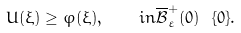<formula> <loc_0><loc_0><loc_500><loc_500>U ( \xi ) \geq \varphi ( \xi ) , \quad i n \overline { \mathcal { B } } ^ { + } _ { \varepsilon } ( 0 ) \ \{ 0 \} .</formula> 